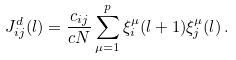Convert formula to latex. <formula><loc_0><loc_0><loc_500><loc_500>J ^ { d } _ { i j } ( l ) = \frac { c _ { i j } } { c N } \sum _ { \mu = 1 } ^ { p } \xi _ { i } ^ { \mu } ( l + 1 ) \xi _ { j } ^ { \mu } ( l ) \, .</formula> 